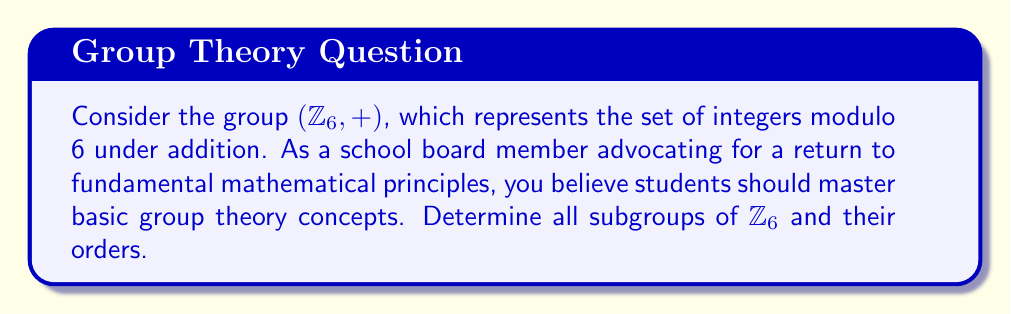Teach me how to tackle this problem. To find all subgroups of $\mathbb{Z}_6$, we'll follow these steps:

1) First, recall that $\mathbb{Z}_6 = \{0, 1, 2, 3, 4, 5\}$ under addition modulo 6.

2) The trivial subgroup $\{0\}$ is always a subgroup of any group.

3) The entire group $\mathbb{Z}_6$ is also always a subgroup of itself.

4) For the remaining subgroups, we need to consider the cyclic subgroups generated by each element:

   $\langle 1 \rangle = \{1, 2, 3, 4, 5, 0\} = \mathbb{Z}_6$
   $\langle 2 \rangle = \{2, 4, 0\} = \{0, 2, 4\}$
   $\langle 3 \rangle = \{3, 0\} = \{0, 3\}$
   $\langle 4 \rangle = \{4, 2, 0\} = \{0, 2, 4\}$
   $\langle 5 \rangle = \{5, 4, 3, 2, 1, 0\} = \mathbb{Z}_6$

5) We can see that $\langle 1 \rangle$ and $\langle 5 \rangle$ generate the entire group.

6) $\langle 2 \rangle$ and $\langle 4 \rangle$ generate the same subgroup $\{0, 2, 4\}$.

7) $\langle 3 \rangle$ generates a unique subgroup $\{0, 3\}$.

Therefore, the distinct subgroups of $\mathbb{Z}_6$ are:

$\{0\}$ (order 1)
$\{0, 3\}$ (order 2)
$\{0, 2, 4\}$ (order 3)
$\mathbb{Z}_6 = \{0, 1, 2, 3, 4, 5\}$ (order 6)
Answer: The subgroups of $\mathbb{Z}_6$ and their orders are:
1) $\{0\}$, order 1
2) $\{0, 3\}$, order 2
3) $\{0, 2, 4\}$, order 3
4) $\{0, 1, 2, 3, 4, 5\}$, order 6 